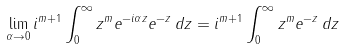Convert formula to latex. <formula><loc_0><loc_0><loc_500><loc_500>\lim _ { \alpha \to 0 } i ^ { m + 1 } \int _ { 0 } ^ { \infty } z ^ { m } e ^ { - i \alpha z } e ^ { - z } \, d z = i ^ { m + 1 } \int _ { 0 } ^ { \infty } z ^ { m } e ^ { - z } \, d z</formula> 